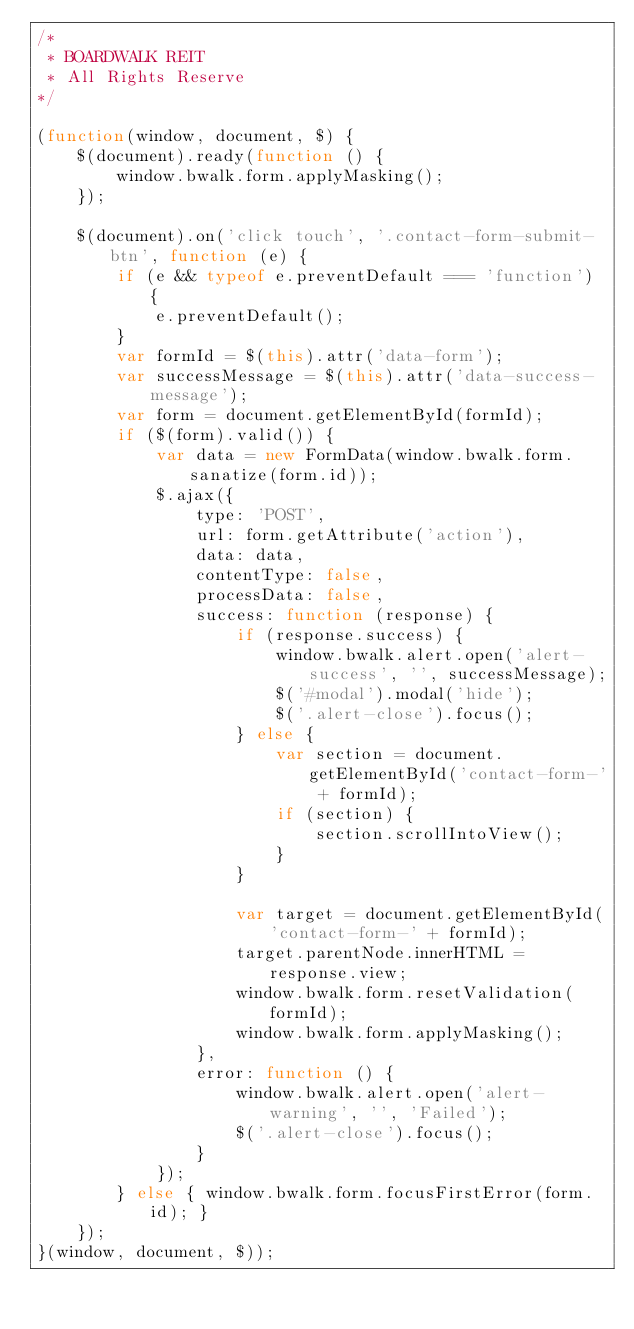<code> <loc_0><loc_0><loc_500><loc_500><_JavaScript_>/*
 * BOARDWALK REIT
 * All Rights Reserve
*/

(function(window, document, $) {
    $(document).ready(function () {
        window.bwalk.form.applyMasking();
    });

    $(document).on('click touch', '.contact-form-submit-btn', function (e) {
        if (e && typeof e.preventDefault === 'function') {
            e.preventDefault();
        }
        var formId = $(this).attr('data-form');
        var successMessage = $(this).attr('data-success-message');
        var form = document.getElementById(formId);
        if ($(form).valid()) {
            var data = new FormData(window.bwalk.form.sanatize(form.id));
            $.ajax({
                type: 'POST',
                url: form.getAttribute('action'),
                data: data,
                contentType: false,
                processData: false,
                success: function (response) {
                    if (response.success) {
                        window.bwalk.alert.open('alert-success', '', successMessage);
                        $('#modal').modal('hide');
                        $('.alert-close').focus();
                    } else {
                        var section = document.getElementById('contact-form-' + formId);
                        if (section) {
                            section.scrollIntoView();
                        }
                    }

                    var target = document.getElementById('contact-form-' + formId);
                    target.parentNode.innerHTML = response.view;
                    window.bwalk.form.resetValidation(formId);
                    window.bwalk.form.applyMasking();
                },
                error: function () {
                    window.bwalk.alert.open('alert-warning', '', 'Failed');
                    $('.alert-close').focus();
                }
            });
        } else { window.bwalk.form.focusFirstError(form.id); }
    });
}(window, document, $));
</code> 